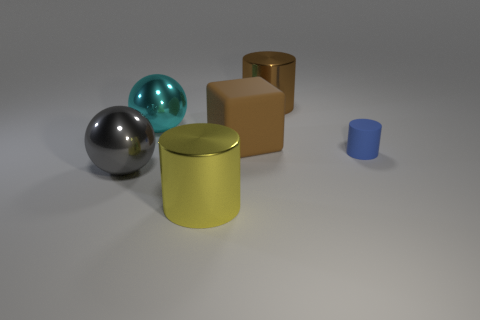Add 2 cylinders. How many objects exist? 8 Subtract all blocks. How many objects are left? 5 Subtract 0 purple balls. How many objects are left? 6 Subtract all metallic cylinders. Subtract all big brown matte blocks. How many objects are left? 3 Add 5 yellow metallic cylinders. How many yellow metallic cylinders are left? 6 Add 5 large brown blocks. How many large brown blocks exist? 6 